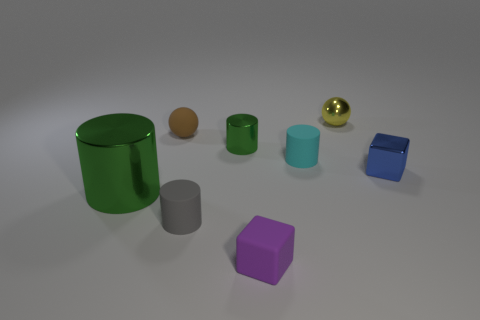Add 1 green metallic cylinders. How many objects exist? 9 Subtract all cubes. How many objects are left? 6 Subtract all matte cylinders. Subtract all tiny green cylinders. How many objects are left? 5 Add 6 blue metal things. How many blue metal things are left? 7 Add 2 tiny red objects. How many tiny red objects exist? 2 Subtract 0 brown cylinders. How many objects are left? 8 